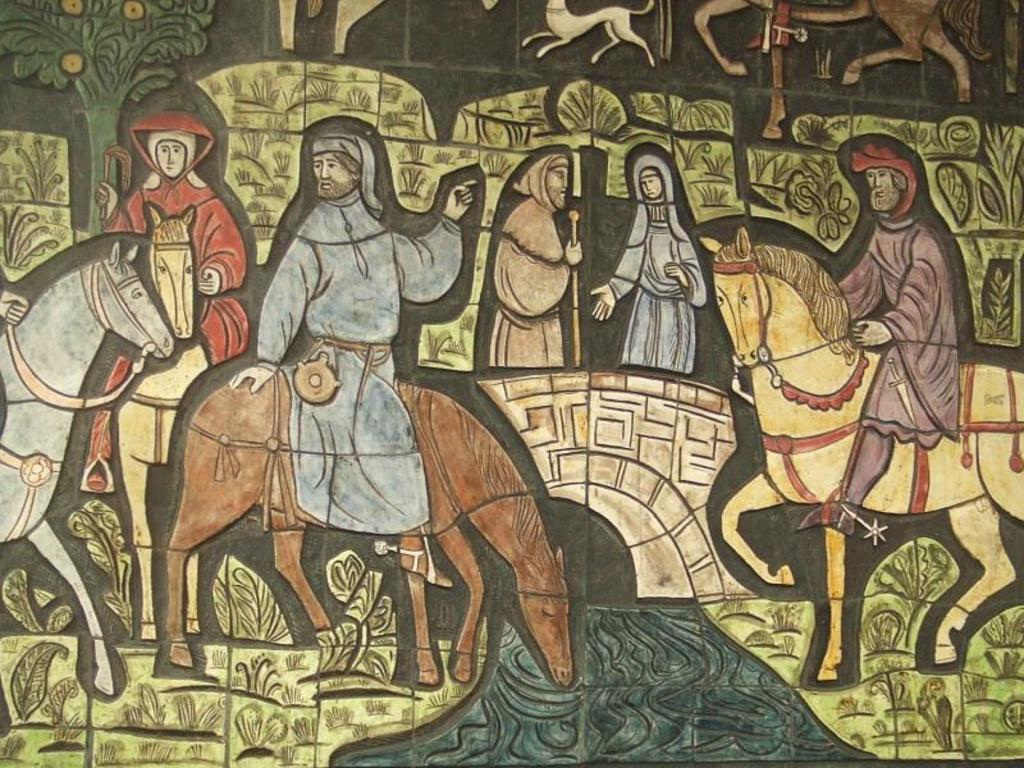What can be seen on the wall in the image? There is a design on the wall in the image. What is depicted in the design? The design features persons sitting on a horse. How many persons are in the center of the design? There are two persons in the center of the design. What type of berry is being used to soothe the person's throat in the image? There is no berry or person with a sore throat depicted in the image; it features a design of persons sitting on a horse. 